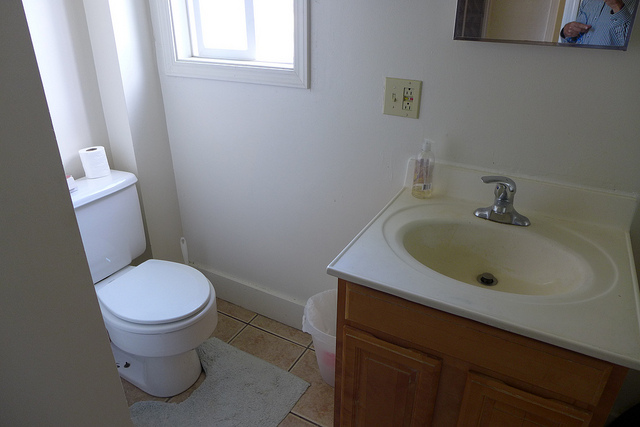How many windows? 1 